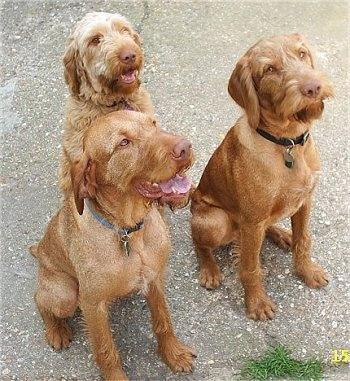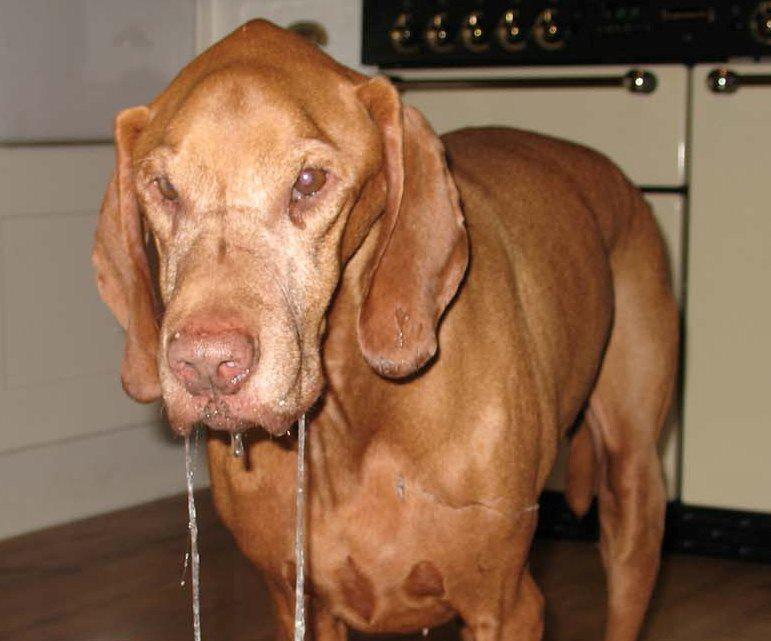The first image is the image on the left, the second image is the image on the right. For the images shown, is this caption "there are two dogs in the image pair" true? Answer yes or no. No. The first image is the image on the left, the second image is the image on the right. Evaluate the accuracy of this statement regarding the images: "The left image contains at least two dogs.". Is it true? Answer yes or no. Yes. 